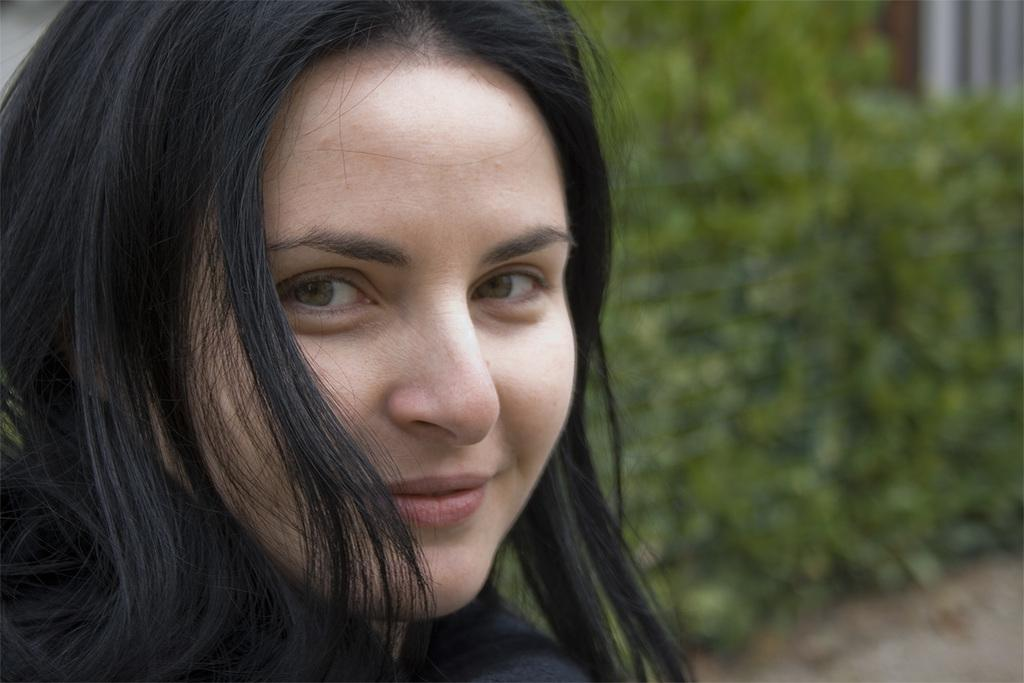Where was the image taken? The image was taken outdoors. What can be seen in the background of the image? There are plants with green leaves and stems in the background. Can you describe the woman in the image? There is a woman on the left side of the image, and she has a smiling face. What type of apple is the woman holding in the image? There is no apple present in the image; the woman does not have any object in her hands. 